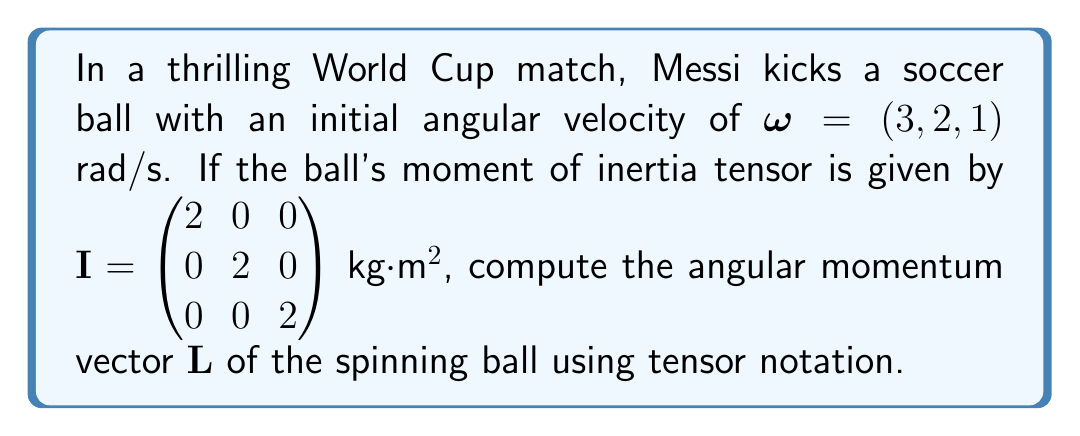Give your solution to this math problem. To solve this problem, we'll follow these steps:

1) The angular momentum vector $\mathbf{L}$ is given by the tensor equation:

   $$\mathbf{L} = I \cdot \boldsymbol{\omega}$$

   where $I$ is the moment of inertia tensor and $\boldsymbol{\omega}$ is the angular velocity vector.

2) We're given:
   
   $$I = \begin{pmatrix} 2 & 0 & 0 \\ 0 & 2 & 0 \\ 0 & 0 & 2 \end{pmatrix} \text{ kg·m²}$$
   
   $$\boldsymbol{\omega} = (3, 2, 1) \text{ rad/s}$$

3) To perform the matrix multiplication, we'll use the following:

   $$\begin{pmatrix} 2 & 0 & 0 \\ 0 & 2 & 0 \\ 0 & 0 & 2 \end{pmatrix} \cdot \begin{pmatrix} 3 \\ 2 \\ 1 \end{pmatrix}$$

4) Multiplying each row of $I$ by $\boldsymbol{\omega}$:

   First row: $2(3) + 0(2) + 0(1) = 6$
   Second row: $0(3) + 2(2) + 0(1) = 4$
   Third row: $0(3) + 0(2) + 2(1) = 2$

5) Therefore, the angular momentum vector is:

   $$\mathbf{L} = (6, 4, 2) \text{ kg·m²/s}$$

This represents the angular momentum of Messi's perfectly kicked ball as it spins through the air towards the goal.
Answer: $\mathbf{L} = (6, 4, 2)$ kg·m²/s 